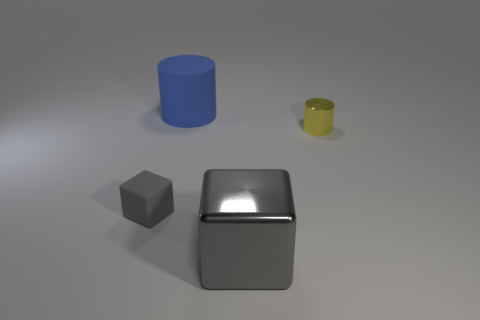Is there any other thing that has the same shape as the big gray thing?
Give a very brief answer. Yes. The big cube that is the same material as the yellow cylinder is what color?
Provide a succinct answer. Gray. What number of things are either brown spheres or big metal things?
Provide a succinct answer. 1. Is the size of the metallic block the same as the gray object that is on the left side of the large metal block?
Give a very brief answer. No. There is a rubber thing right of the small thing on the left side of the shiny thing that is in front of the yellow metallic object; what color is it?
Provide a succinct answer. Blue. The large matte object is what color?
Provide a succinct answer. Blue. Are there more things on the left side of the yellow metal thing than tiny yellow things behind the blue rubber cylinder?
Keep it short and to the point. Yes. Do the small shiny object and the big object that is behind the small gray cube have the same shape?
Your answer should be very brief. Yes. There is a gray cube behind the large shiny object; is its size the same as the shiny object that is on the right side of the large shiny thing?
Provide a succinct answer. Yes. There is a cylinder on the right side of the gray cube that is in front of the tiny gray matte object; are there any matte objects that are in front of it?
Your answer should be compact. Yes. 